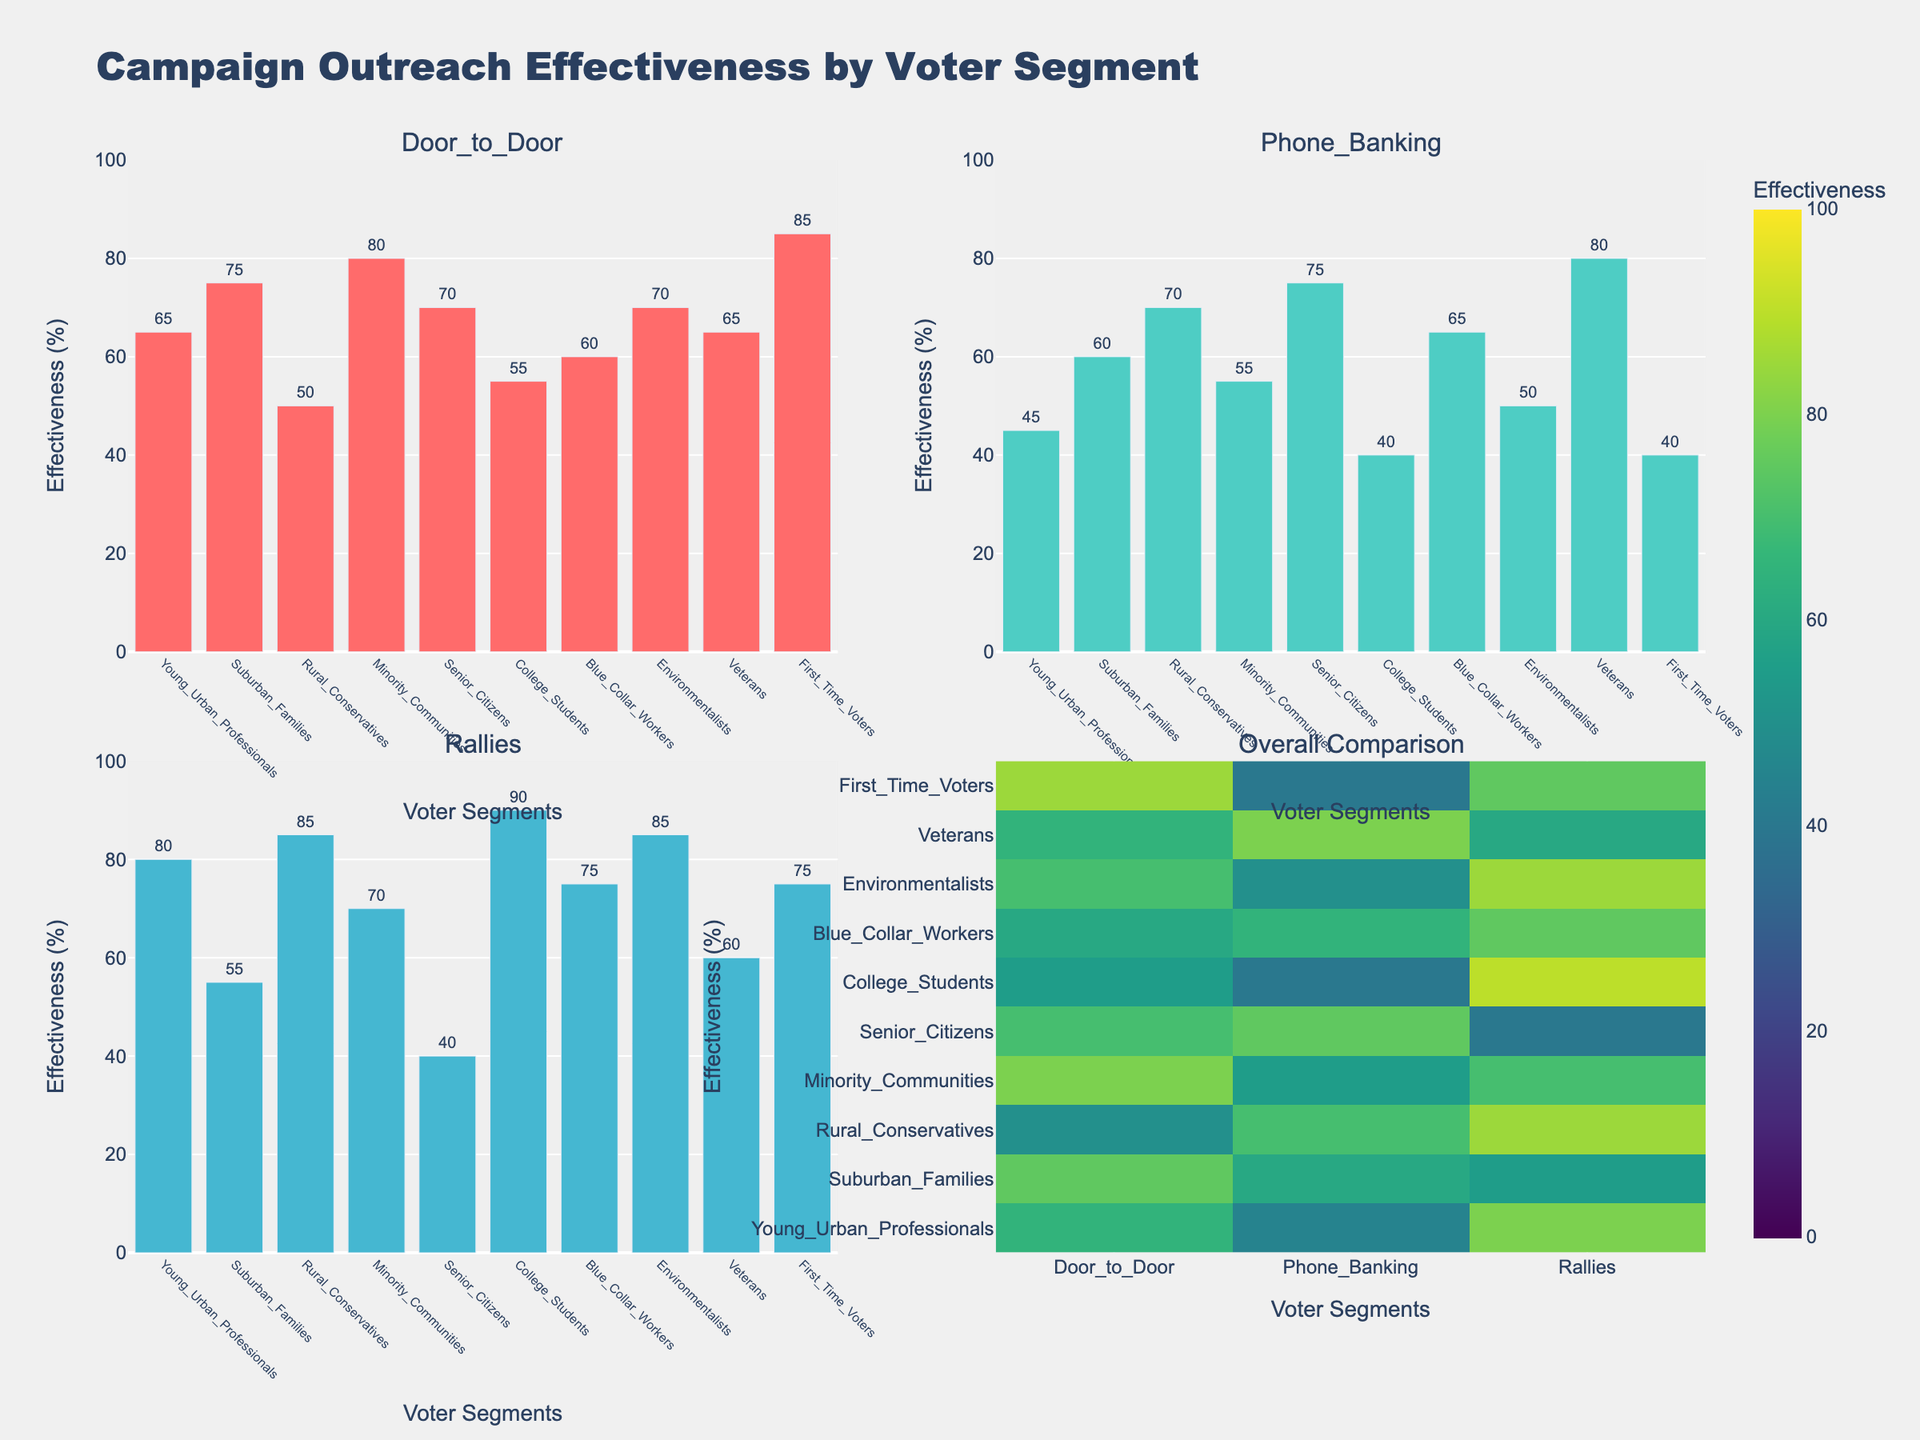What is the title of the plot? The plot title is prominently displayed at the top.
Answer: Campaign Outreach Effectiveness by Voter Segment Which campaign outreach method is most effective among College Students? Looking at the bar heights in the College Students category across the subplots, the tallest bar corresponds to Rallies.
Answer: Rallies What is the effectiveness of Phone Banking for Rural Conservatives? In the Phone Banking subplot, the bar corresponding to Rural Conservatives has a height of 70.
Answer: 70 Compare the effectiveness of Door-to-Door and Rallies for Minority Communities. Which method is more effective? By observing the bar heights for Minority Communities in the Door-to-Door and Rallies subplots, the Door-to-Door bar is shorter at 80 compared to the Rallies bar at 70.
Answer: Door-to-Door Which voter segment shows the highest effectiveness for Door-to-Door method? In the Door-to-Door subplot, the bar with the greatest height among voter segments is First Time Voters.
Answer: First Time Voters What is the average effectiveness of Door-to-Door method across all voter segments? Sum of Door-to-Door values: 65+75+50+80+70+55+60+70+65+85 = 675. Number of segments: 10. Average = 675/10.
Answer: 67.5 How does the effectiveness of Phone Banking vary between Suburban Families and Young Urban Professionals? In the Phone Banking subplot, compare the heights of the bars corresponding to Suburban Families (60) and Young Urban Professionals (45).
Answer: Suburban Families is more effective than Young Urban Professionals Which outreach method tends to have the highest overall effectiveness across all voter segments? By examining the heatmap, Rallies consistently show higher effectiveness scores in darker colors compared to other methods.
Answer: Rallies Identify the voter segment with the lowest effectiveness for Rallies. In the Rallies subplot, the lowest bar corresponds to Senior Citizens.
Answer: Senior Citizens Which two voter segments have the closest effectiveness scores for Door-to-Door method? In the Door-to-Door subplot, Blue Collar Workers (60) and Young Urban Professionals (65) have the closest scores.
Answer: Blue Collar Workers and Young Urban Professionals 